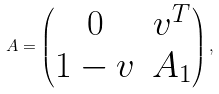Convert formula to latex. <formula><loc_0><loc_0><loc_500><loc_500>A = \begin{pmatrix} 0 & v ^ { T } \\ 1 - v & A _ { 1 } \end{pmatrix} ,</formula> 